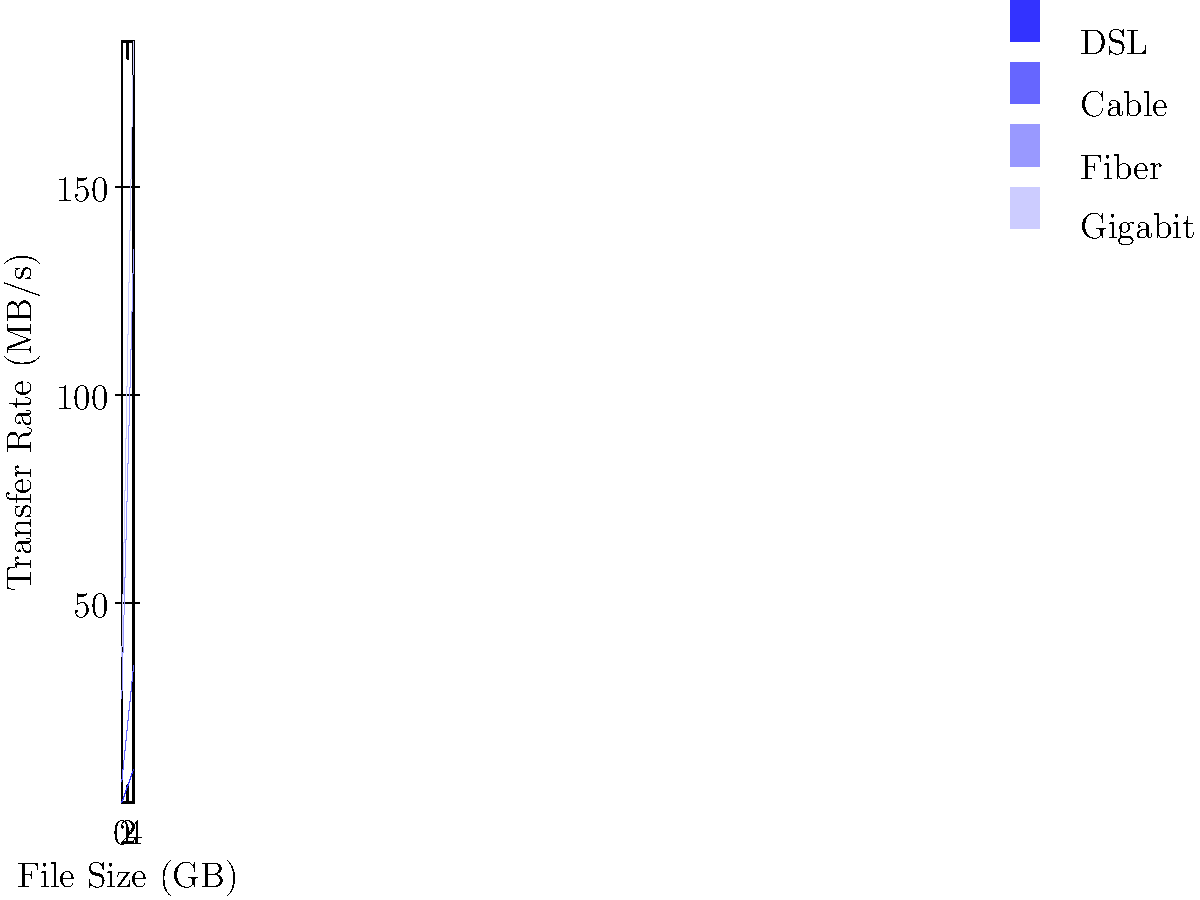Well, well, well, if it isn't the battle of the bandwidth! Looking at this stacked area chart of data transfer rates, which network type shows the most consistent rate of increase across different file sizes? And for the love of all things digital, please quantify your answer with the actual rate of increase per GB. Alright, let's break this down with the sarcastic precision of a true tech aficionado:

1. We need to calculate the rate of increase for each network type:
   
   DSL: 
   $\frac{10 - 2}{4} = 2$ MB/s per GB
   
   Cable: 
   $\frac{25 - 5}{4} = 5$ MB/s per GB
   
   Fiber: 
   $\frac{100 - 20}{4} = 20$ MB/s per GB
   
   Gigabit: 
   $\frac{50 - 10}{4} = 10$ MB/s per GB

2. Now, let's look at the consistency of these increases:
   - DSL and Cable show a perfectly linear increase (as if they're trying to impress us with their predictability).
   - Fiber and Gigabit also show linear increases, but they're just showing off with bigger numbers.

3. The most consistent rate of increase is shared by DSL and Cable, as they maintain a perfectly steady slope throughout the graph.

4. However, since we're asked to quantify with the actual rate of increase, we'll go with Cable, because it has a higher rate than DSL (5 MB/s per GB vs 2 MB/s per GB).

5. Cable it is, then. Not the fastest kid on the block, but at least it's reliable in its mediocrity.
Answer: Cable, with 5 MB/s per GB 